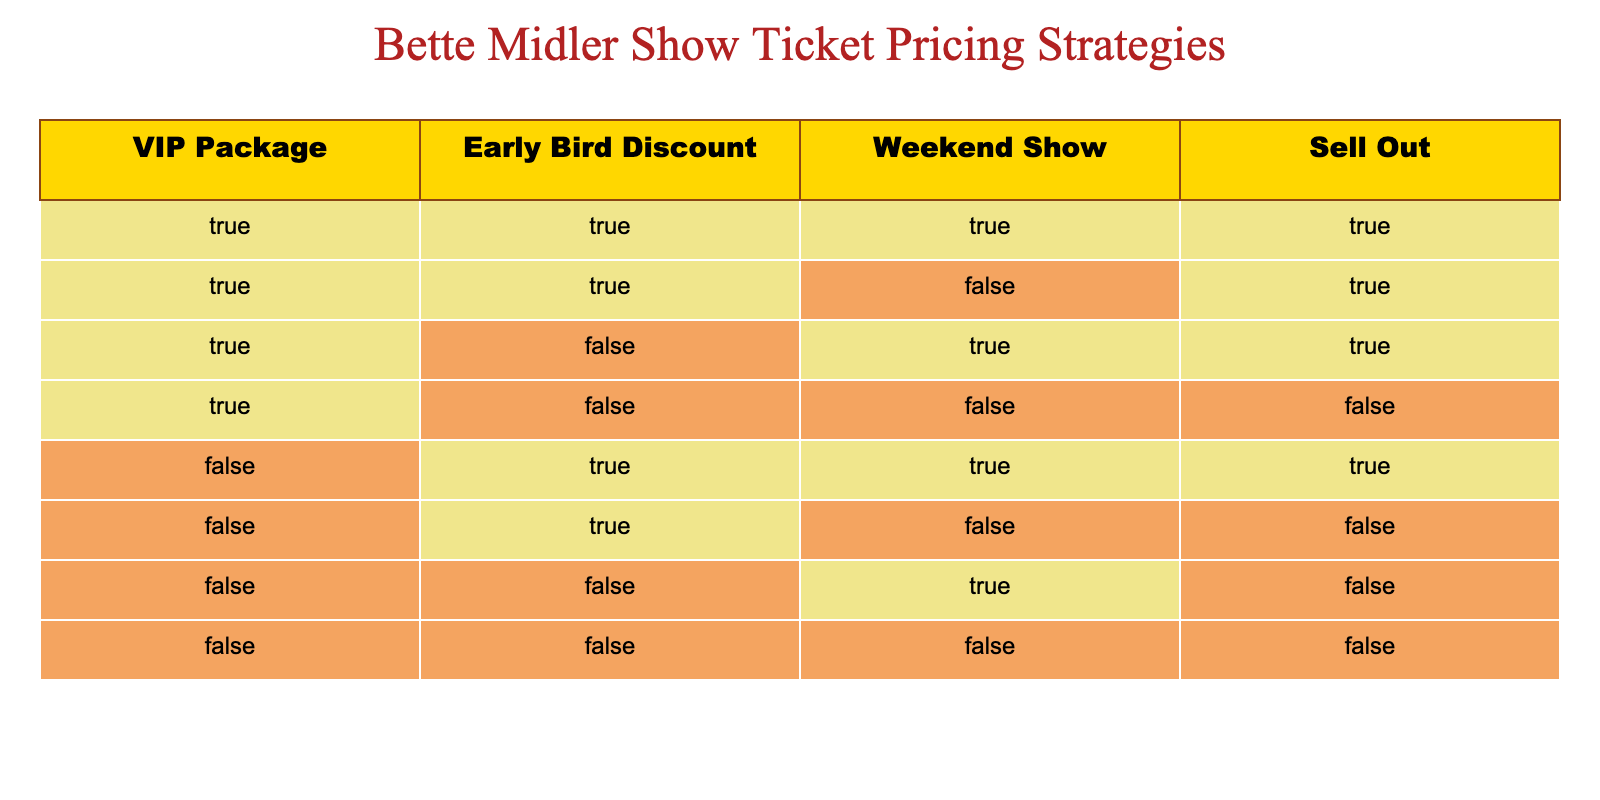What is the total number of scenarios where the VIP package is offered? To find this, I count the rows where the VIP Package is marked as true. There are four rows (1, 2, 3, 4) that show the VIP Package as true.
Answer: 4 Is there any scenario that offers both the Early Bird Discount and the Weekend Show? I look for rows that have both the Early Bird Discount and the Weekend Show marked as true. Rows 1, 2, and 5 meet this condition, confirming there are multiple such scenarios.
Answer: Yes How many scenarios resulted in a sell-out? Counting the rows where the Sell Out column is true gives me four rows (1, 2, 3, 5) resulting in a sell-out.
Answer: 4 What is the percentage of situations with both the VIP Package and the Early Bird Discount that led to a sell-out? I identify the rows where both the VIP Package and the Early Bird Discount are true, which yields rows 1 and 2 (2 scenarios). Among them, both resulted in sell-out (true), making it 100%. Therefore, the percentage is (2/2) * 100 = 100%.
Answer: 100% Are there any scenarios without a VIP Package that still sold out? I look for rows that have the VIP Package marked as false and check if the Sell Out column is true. Upon checking rows 5, 6, and 7, only row 5 sold out.
Answer: Yes How many total scenarios were there when both Weekend Show and Sell Out are true? I count the instances where the Weekend Show and Sell Out columns are both marked true. These are rows 1 and 3, giving me 2 total scenarios.
Answer: 2 What is the ratio of scenarios with an Early Bird Discount to those that sold out? I find two scenarios with the Early Bird Discount (rows 1 and 5) and four scenarios that sold out. The ratio is 2:4, which simplifies down to 1:2.
Answer: 1:2 How many scenarios had no discounts or VIP packages and did not sell out? I check for rows with false values in both the VIP Package and Early Bird Discount columns, and also check the Sell Out column. Row 7 meets all these conditions, yielding 1 scenario.
Answer: 1 In how many scenarios was the VIP Package present but did not lead to a sell-out? I count the rows where the VIP Package is true and the Sell Out is false. Only row 4 meets this condition, giving me 1 scenario.
Answer: 1 